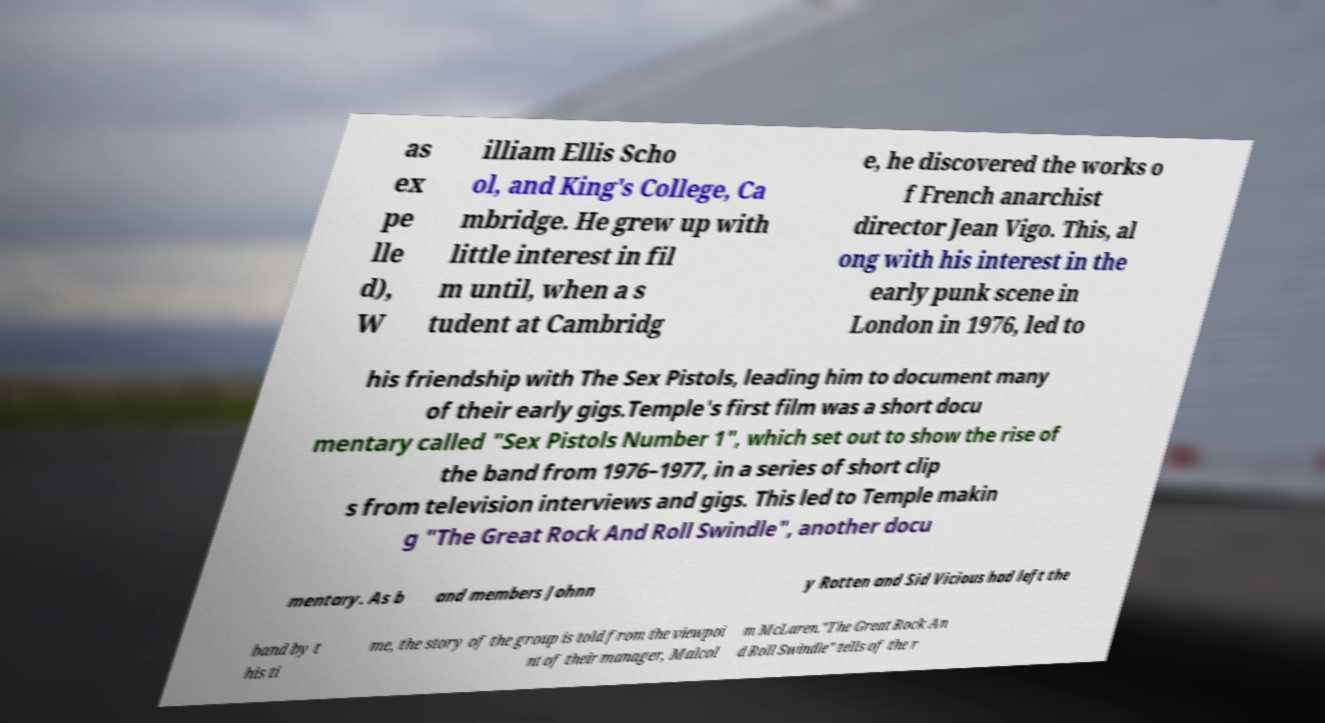What messages or text are displayed in this image? I need them in a readable, typed format. as ex pe lle d), W illiam Ellis Scho ol, and King's College, Ca mbridge. He grew up with little interest in fil m until, when a s tudent at Cambridg e, he discovered the works o f French anarchist director Jean Vigo. This, al ong with his interest in the early punk scene in London in 1976, led to his friendship with The Sex Pistols, leading him to document many of their early gigs.Temple's first film was a short docu mentary called "Sex Pistols Number 1", which set out to show the rise of the band from 1976–1977, in a series of short clip s from television interviews and gigs. This led to Temple makin g "The Great Rock And Roll Swindle", another docu mentary. As b and members Johnn y Rotten and Sid Vicious had left the band by t his ti me, the story of the group is told from the viewpoi nt of their manager, Malcol m McLaren."The Great Rock An d Roll Swindle" tells of the r 